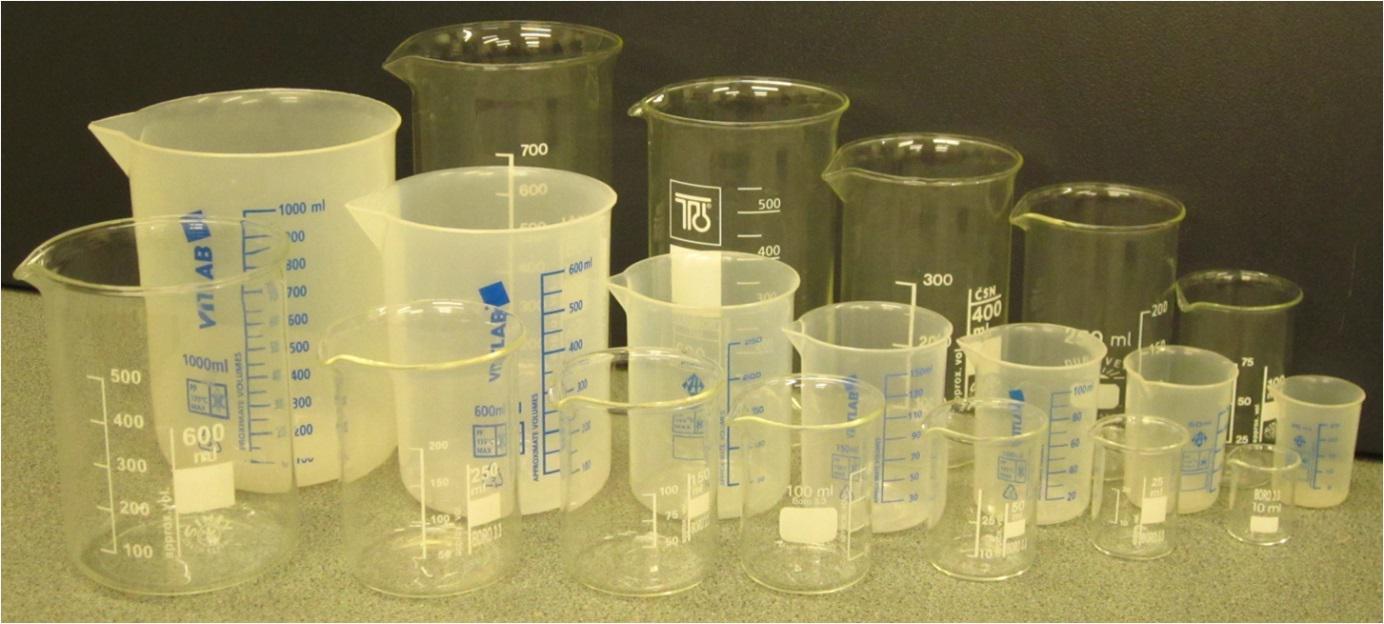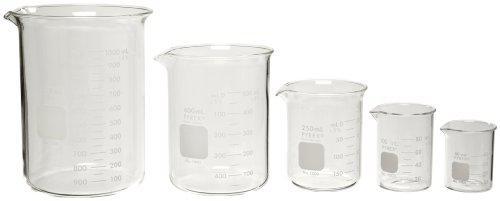The first image is the image on the left, the second image is the image on the right. Considering the images on both sides, is "Each image shows a group of overlapping beakers, all containing colored liquid." valid? Answer yes or no. No. The first image is the image on the left, the second image is the image on the right. For the images displayed, is the sentence "Two beakers contain red liquid." factually correct? Answer yes or no. No. 